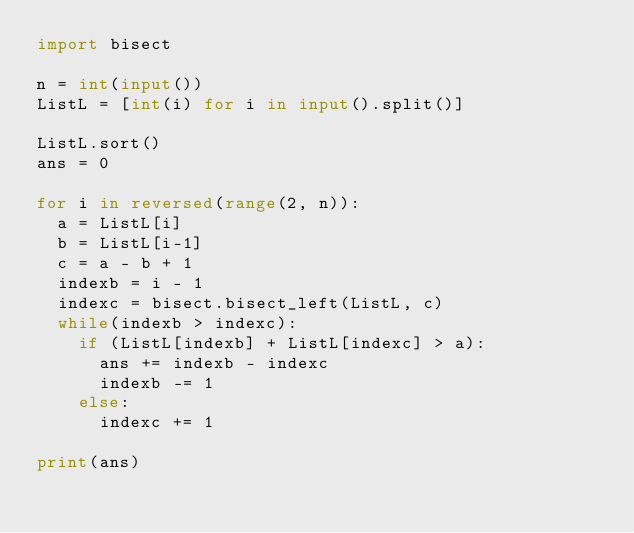Convert code to text. <code><loc_0><loc_0><loc_500><loc_500><_Python_>import bisect

n = int(input())
ListL = [int(i) for i in input().split()]

ListL.sort()
ans = 0

for i in reversed(range(2, n)):
	a = ListL[i]
	b = ListL[i-1]
	c = a - b + 1
	indexb = i - 1
	indexc = bisect.bisect_left(ListL, c)
	while(indexb > indexc):
		if (ListL[indexb] + ListL[indexc] > a):
			ans += indexb - indexc
			indexb -= 1
		else:
			indexc += 1

print(ans)</code> 